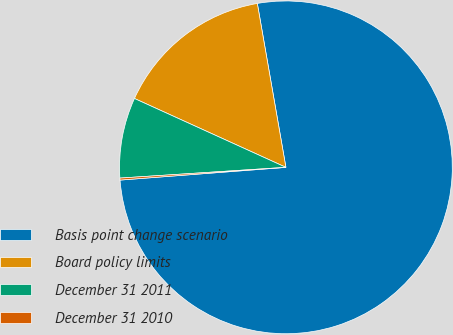Convert chart. <chart><loc_0><loc_0><loc_500><loc_500><pie_chart><fcel>Basis point change scenario<fcel>Board policy limits<fcel>December 31 2011<fcel>December 31 2010<nl><fcel>76.53%<fcel>15.46%<fcel>7.82%<fcel>0.19%<nl></chart> 